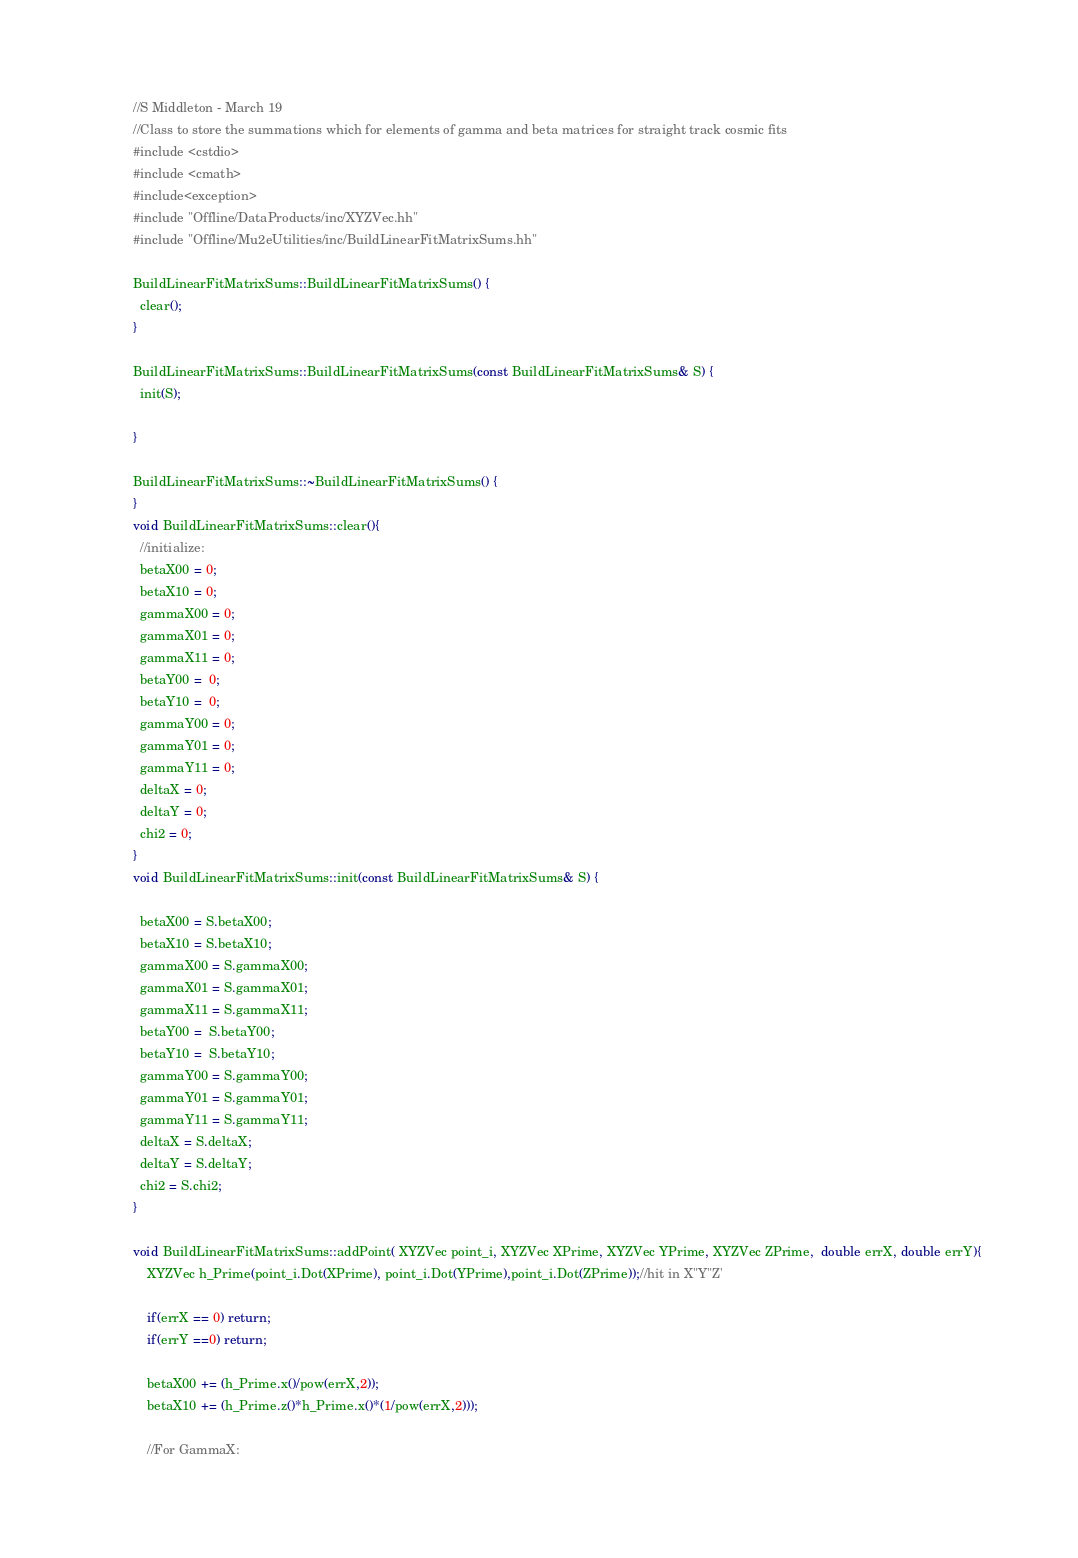<code> <loc_0><loc_0><loc_500><loc_500><_C++_>//S Middleton - March 19
//Class to store the summations which for elements of gamma and beta matrices for straight track cosmic fits
#include <cstdio>
#include <cmath>
#include<exception>
#include "Offline/DataProducts/inc/XYZVec.hh"
#include "Offline/Mu2eUtilities/inc/BuildLinearFitMatrixSums.hh"

BuildLinearFitMatrixSums::BuildLinearFitMatrixSums() {
  clear();
}

BuildLinearFitMatrixSums::BuildLinearFitMatrixSums(const BuildLinearFitMatrixSums& S) {
  init(S);
 
}

BuildLinearFitMatrixSums::~BuildLinearFitMatrixSums() {
}
void BuildLinearFitMatrixSums::clear(){
  //initialize:
  betaX00 = 0;
  betaX10 = 0;
  gammaX00 = 0;
  gammaX01 = 0;
  gammaX11 = 0;
  betaY00 =  0;
  betaY10 =  0;
  gammaY00 = 0;
  gammaY01 = 0;
  gammaY11 = 0;
  deltaX = 0;
  deltaY = 0;
  chi2 = 0;
}
void BuildLinearFitMatrixSums::init(const BuildLinearFitMatrixSums& S) {
 
  betaX00 = S.betaX00;
  betaX10 = S.betaX10;
  gammaX00 = S.gammaX00;
  gammaX01 = S.gammaX01;
  gammaX11 = S.gammaX11;
  betaY00 =  S.betaY00;
  betaY10 =  S.betaY10;
  gammaY00 = S.gammaY00;
  gammaY01 = S.gammaY01;
  gammaY11 = S.gammaY11;
  deltaX = S.deltaX;
  deltaY = S.deltaY;
  chi2 = S.chi2;
}

void BuildLinearFitMatrixSums::addPoint( XYZVec point_i, XYZVec XPrime, XYZVec YPrime, XYZVec ZPrime,  double errX, double errY){
	XYZVec h_Prime(point_i.Dot(XPrime), point_i.Dot(YPrime),point_i.Dot(ZPrime));//hit in X"Y"Z'

	if(errX == 0) return;
	if(errY ==0) return;

	betaX00 += (h_Prime.x()/pow(errX,2));
	betaX10 += (h_Prime.z()*h_Prime.x()*(1/pow(errX,2)));

	//For GammaX:</code> 